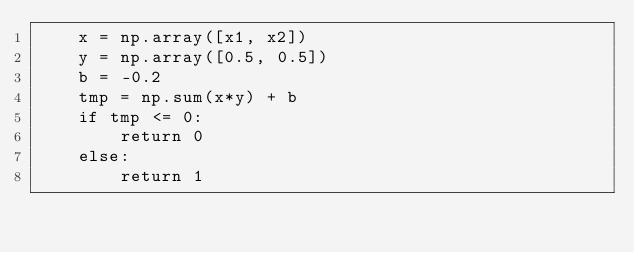Convert code to text. <code><loc_0><loc_0><loc_500><loc_500><_Python_>    x = np.array([x1, x2])
    y = np.array([0.5, 0.5])
    b = -0.2
    tmp = np.sum(x*y) + b
    if tmp <= 0:
        return 0
    else:
        return 1
</code> 